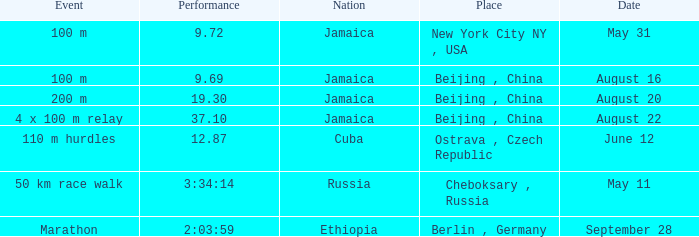Where did jamaica accomplish a 19.30-second performance? Beijing , China. 